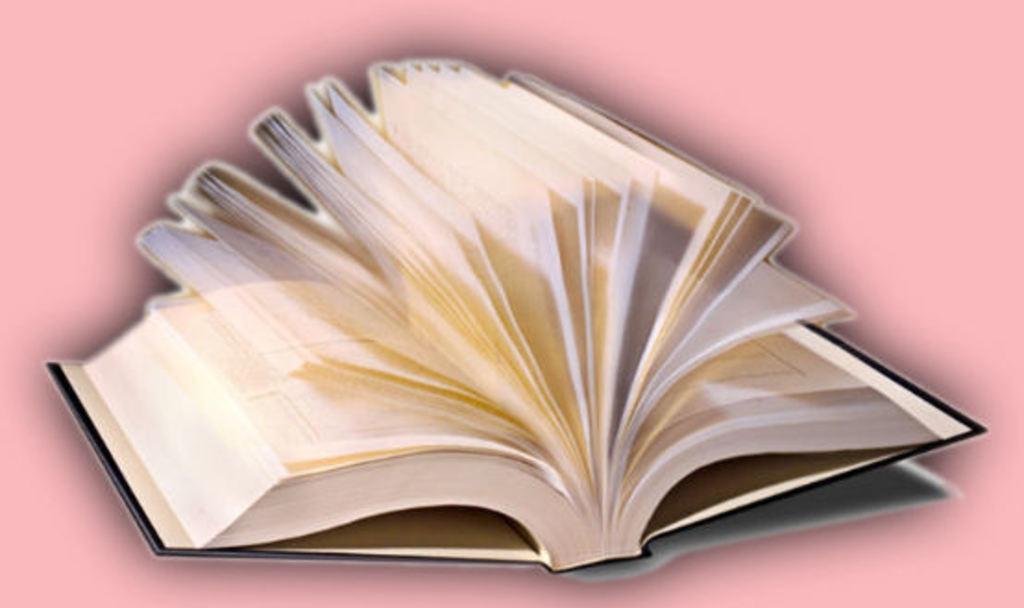Describe this image in one or two sentences. In this picture there is a book which is opened and the background is in pink color. 